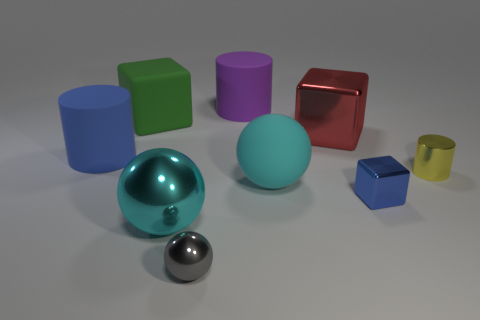How big is the cube on the left side of the small sphere?
Provide a succinct answer. Large. What is the shape of the blue object behind the cylinder that is in front of the blue object that is behind the metal cylinder?
Keep it short and to the point. Cylinder. What is the shape of the large thing that is in front of the blue rubber cylinder and to the left of the tiny gray metal thing?
Your answer should be compact. Sphere. Are there any brown balls that have the same size as the red cube?
Provide a succinct answer. No. There is a big rubber thing in front of the metallic cylinder; is it the same shape as the big cyan metallic thing?
Give a very brief answer. Yes. Is the large red object the same shape as the tiny gray shiny object?
Make the answer very short. No. Are there any large purple rubber things of the same shape as the tiny yellow metal thing?
Give a very brief answer. Yes. There is a big object to the left of the large block left of the matte ball; what is its shape?
Keep it short and to the point. Cylinder. What is the color of the matte thing that is in front of the small yellow object?
Ensure brevity in your answer.  Cyan. What size is the gray thing that is made of the same material as the tiny yellow cylinder?
Offer a terse response. Small. 